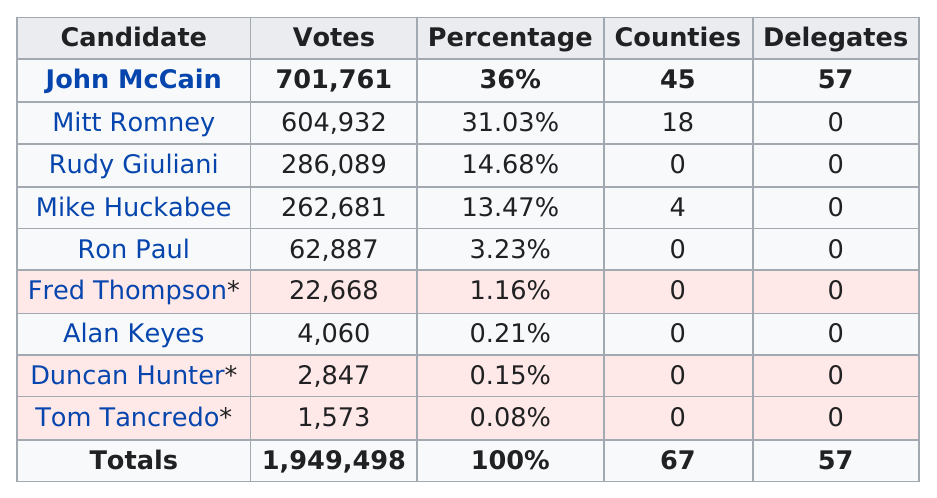Outline some significant characteristics in this image. In the 2005 election for the U.S. House of Representatives in California's 52nd district, Alan Keyes received more votes than Duncan Hunter. There were four candidates who received over 10% of the vote in the election. Alan Keyes received 4,060 votes in the election. The difference in votes between John McCain and Mitt Romney in the 2008 and 2012 presidential elections was approximately 96,829 votes. Four candidates received at least 100,000 votes in the last election. 